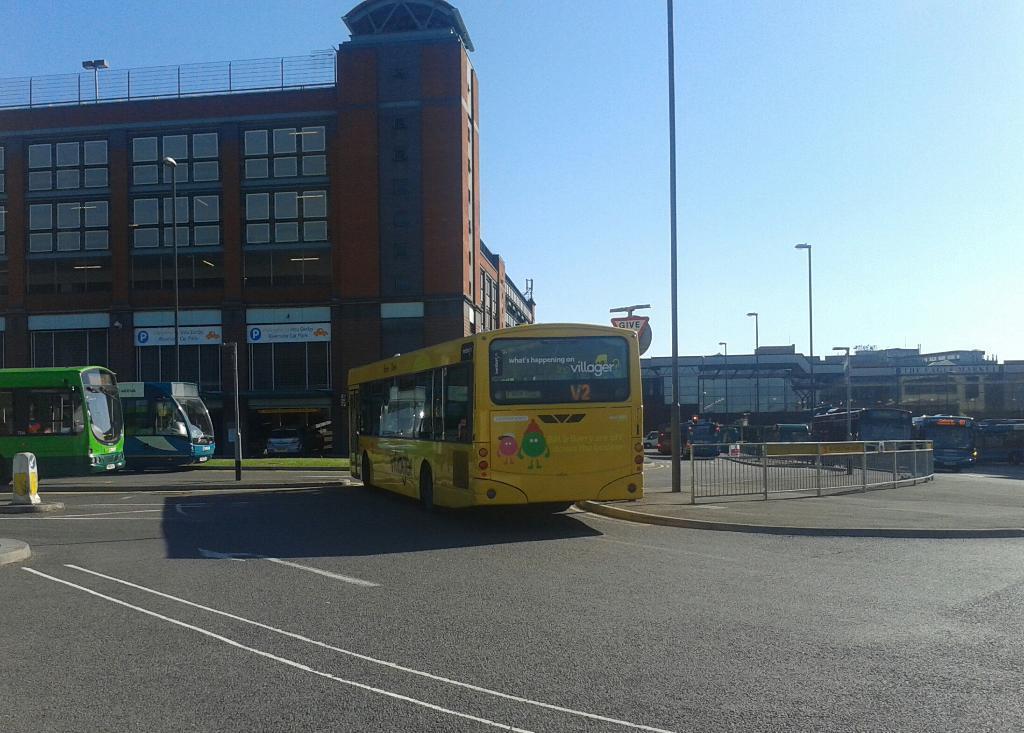Describe this image in one or two sentences. In the foreground of this image, there is a road and few buses on it. We can also see poles and railing on the pavement. In the background there are buses, buildings and the sky. 